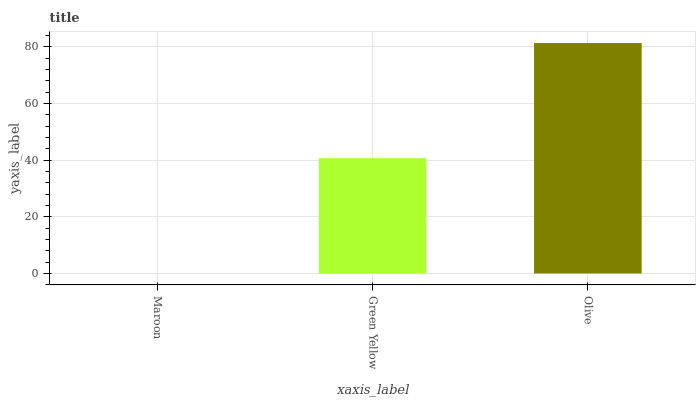Is Maroon the minimum?
Answer yes or no. Yes. Is Olive the maximum?
Answer yes or no. Yes. Is Green Yellow the minimum?
Answer yes or no. No. Is Green Yellow the maximum?
Answer yes or no. No. Is Green Yellow greater than Maroon?
Answer yes or no. Yes. Is Maroon less than Green Yellow?
Answer yes or no. Yes. Is Maroon greater than Green Yellow?
Answer yes or no. No. Is Green Yellow less than Maroon?
Answer yes or no. No. Is Green Yellow the high median?
Answer yes or no. Yes. Is Green Yellow the low median?
Answer yes or no. Yes. Is Olive the high median?
Answer yes or no. No. Is Olive the low median?
Answer yes or no. No. 